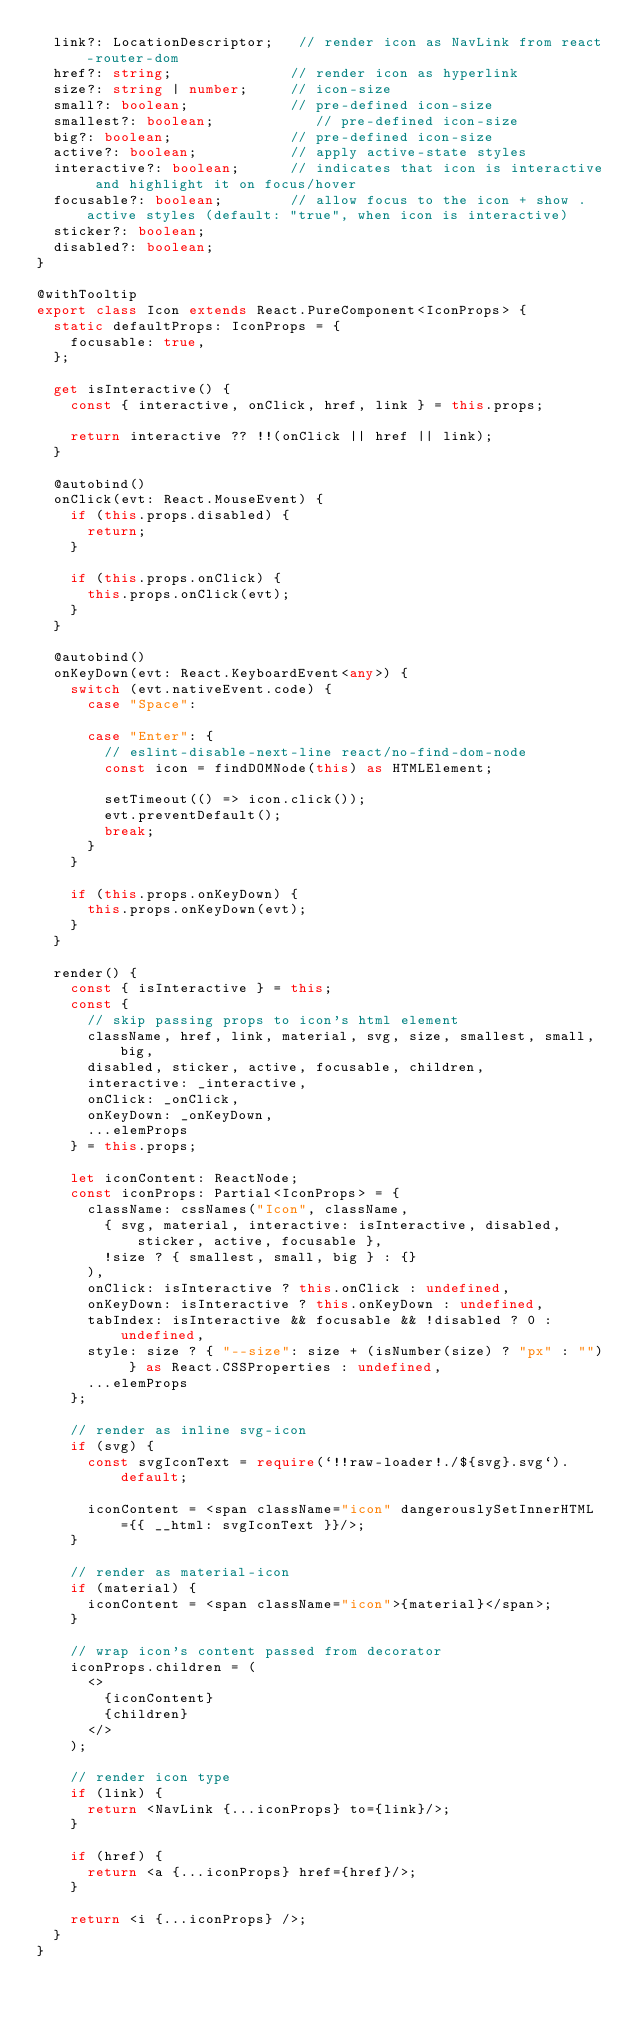Convert code to text. <code><loc_0><loc_0><loc_500><loc_500><_TypeScript_>  link?: LocationDescriptor;   // render icon as NavLink from react-router-dom
  href?: string;              // render icon as hyperlink
  size?: string | number;     // icon-size
  small?: boolean;            // pre-defined icon-size
  smallest?: boolean;            // pre-defined icon-size
  big?: boolean;              // pre-defined icon-size
  active?: boolean;           // apply active-state styles
  interactive?: boolean;      // indicates that icon is interactive and highlight it on focus/hover
  focusable?: boolean;        // allow focus to the icon + show .active styles (default: "true", when icon is interactive)
  sticker?: boolean;
  disabled?: boolean;
}

@withTooltip
export class Icon extends React.PureComponent<IconProps> {
  static defaultProps: IconProps = {
    focusable: true,
  };

  get isInteractive() {
    const { interactive, onClick, href, link } = this.props;

    return interactive ?? !!(onClick || href || link);
  }

  @autobind()
  onClick(evt: React.MouseEvent) {
    if (this.props.disabled) {
      return;
    }

    if (this.props.onClick) {
      this.props.onClick(evt);
    }
  }

  @autobind()
  onKeyDown(evt: React.KeyboardEvent<any>) {
    switch (evt.nativeEvent.code) {
      case "Space":

      case "Enter": {
        // eslint-disable-next-line react/no-find-dom-node
        const icon = findDOMNode(this) as HTMLElement;

        setTimeout(() => icon.click());
        evt.preventDefault();
        break;
      }
    }

    if (this.props.onKeyDown) {
      this.props.onKeyDown(evt);
    }
  }

  render() {
    const { isInteractive } = this;
    const {
      // skip passing props to icon's html element
      className, href, link, material, svg, size, smallest, small, big,
      disabled, sticker, active, focusable, children,
      interactive: _interactive,
      onClick: _onClick,
      onKeyDown: _onKeyDown,
      ...elemProps
    } = this.props;

    let iconContent: ReactNode;
    const iconProps: Partial<IconProps> = {
      className: cssNames("Icon", className,
        { svg, material, interactive: isInteractive, disabled, sticker, active, focusable },
        !size ? { smallest, small, big } : {}
      ),
      onClick: isInteractive ? this.onClick : undefined,
      onKeyDown: isInteractive ? this.onKeyDown : undefined,
      tabIndex: isInteractive && focusable && !disabled ? 0 : undefined,
      style: size ? { "--size": size + (isNumber(size) ? "px" : "") } as React.CSSProperties : undefined,
      ...elemProps
    };

    // render as inline svg-icon
    if (svg) {
      const svgIconText = require(`!!raw-loader!./${svg}.svg`).default;

      iconContent = <span className="icon" dangerouslySetInnerHTML={{ __html: svgIconText }}/>;
    }

    // render as material-icon
    if (material) {
      iconContent = <span className="icon">{material}</span>;
    }

    // wrap icon's content passed from decorator
    iconProps.children = (
      <>
        {iconContent}
        {children}
      </>
    );

    // render icon type
    if (link) {
      return <NavLink {...iconProps} to={link}/>;
    }

    if (href) {
      return <a {...iconProps} href={href}/>;
    }

    return <i {...iconProps} />;
  }
}
</code> 